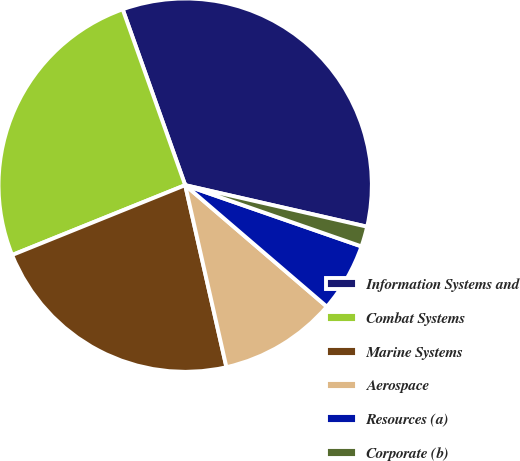Convert chart to OTSL. <chart><loc_0><loc_0><loc_500><loc_500><pie_chart><fcel>Information Systems and<fcel>Combat Systems<fcel>Marine Systems<fcel>Aerospace<fcel>Resources (a)<fcel>Corporate (b)<nl><fcel>34.01%<fcel>25.67%<fcel>22.44%<fcel>10.17%<fcel>5.96%<fcel>1.75%<nl></chart> 